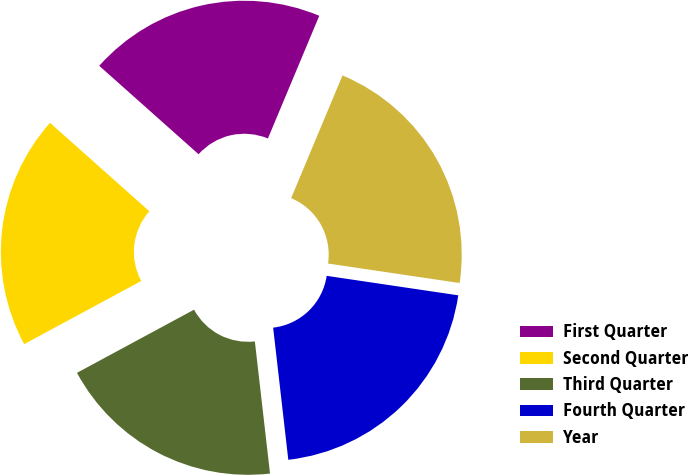<chart> <loc_0><loc_0><loc_500><loc_500><pie_chart><fcel>First Quarter<fcel>Second Quarter<fcel>Third Quarter<fcel>Fourth Quarter<fcel>Year<nl><fcel>19.73%<fcel>19.45%<fcel>18.94%<fcel>20.84%<fcel>21.03%<nl></chart> 